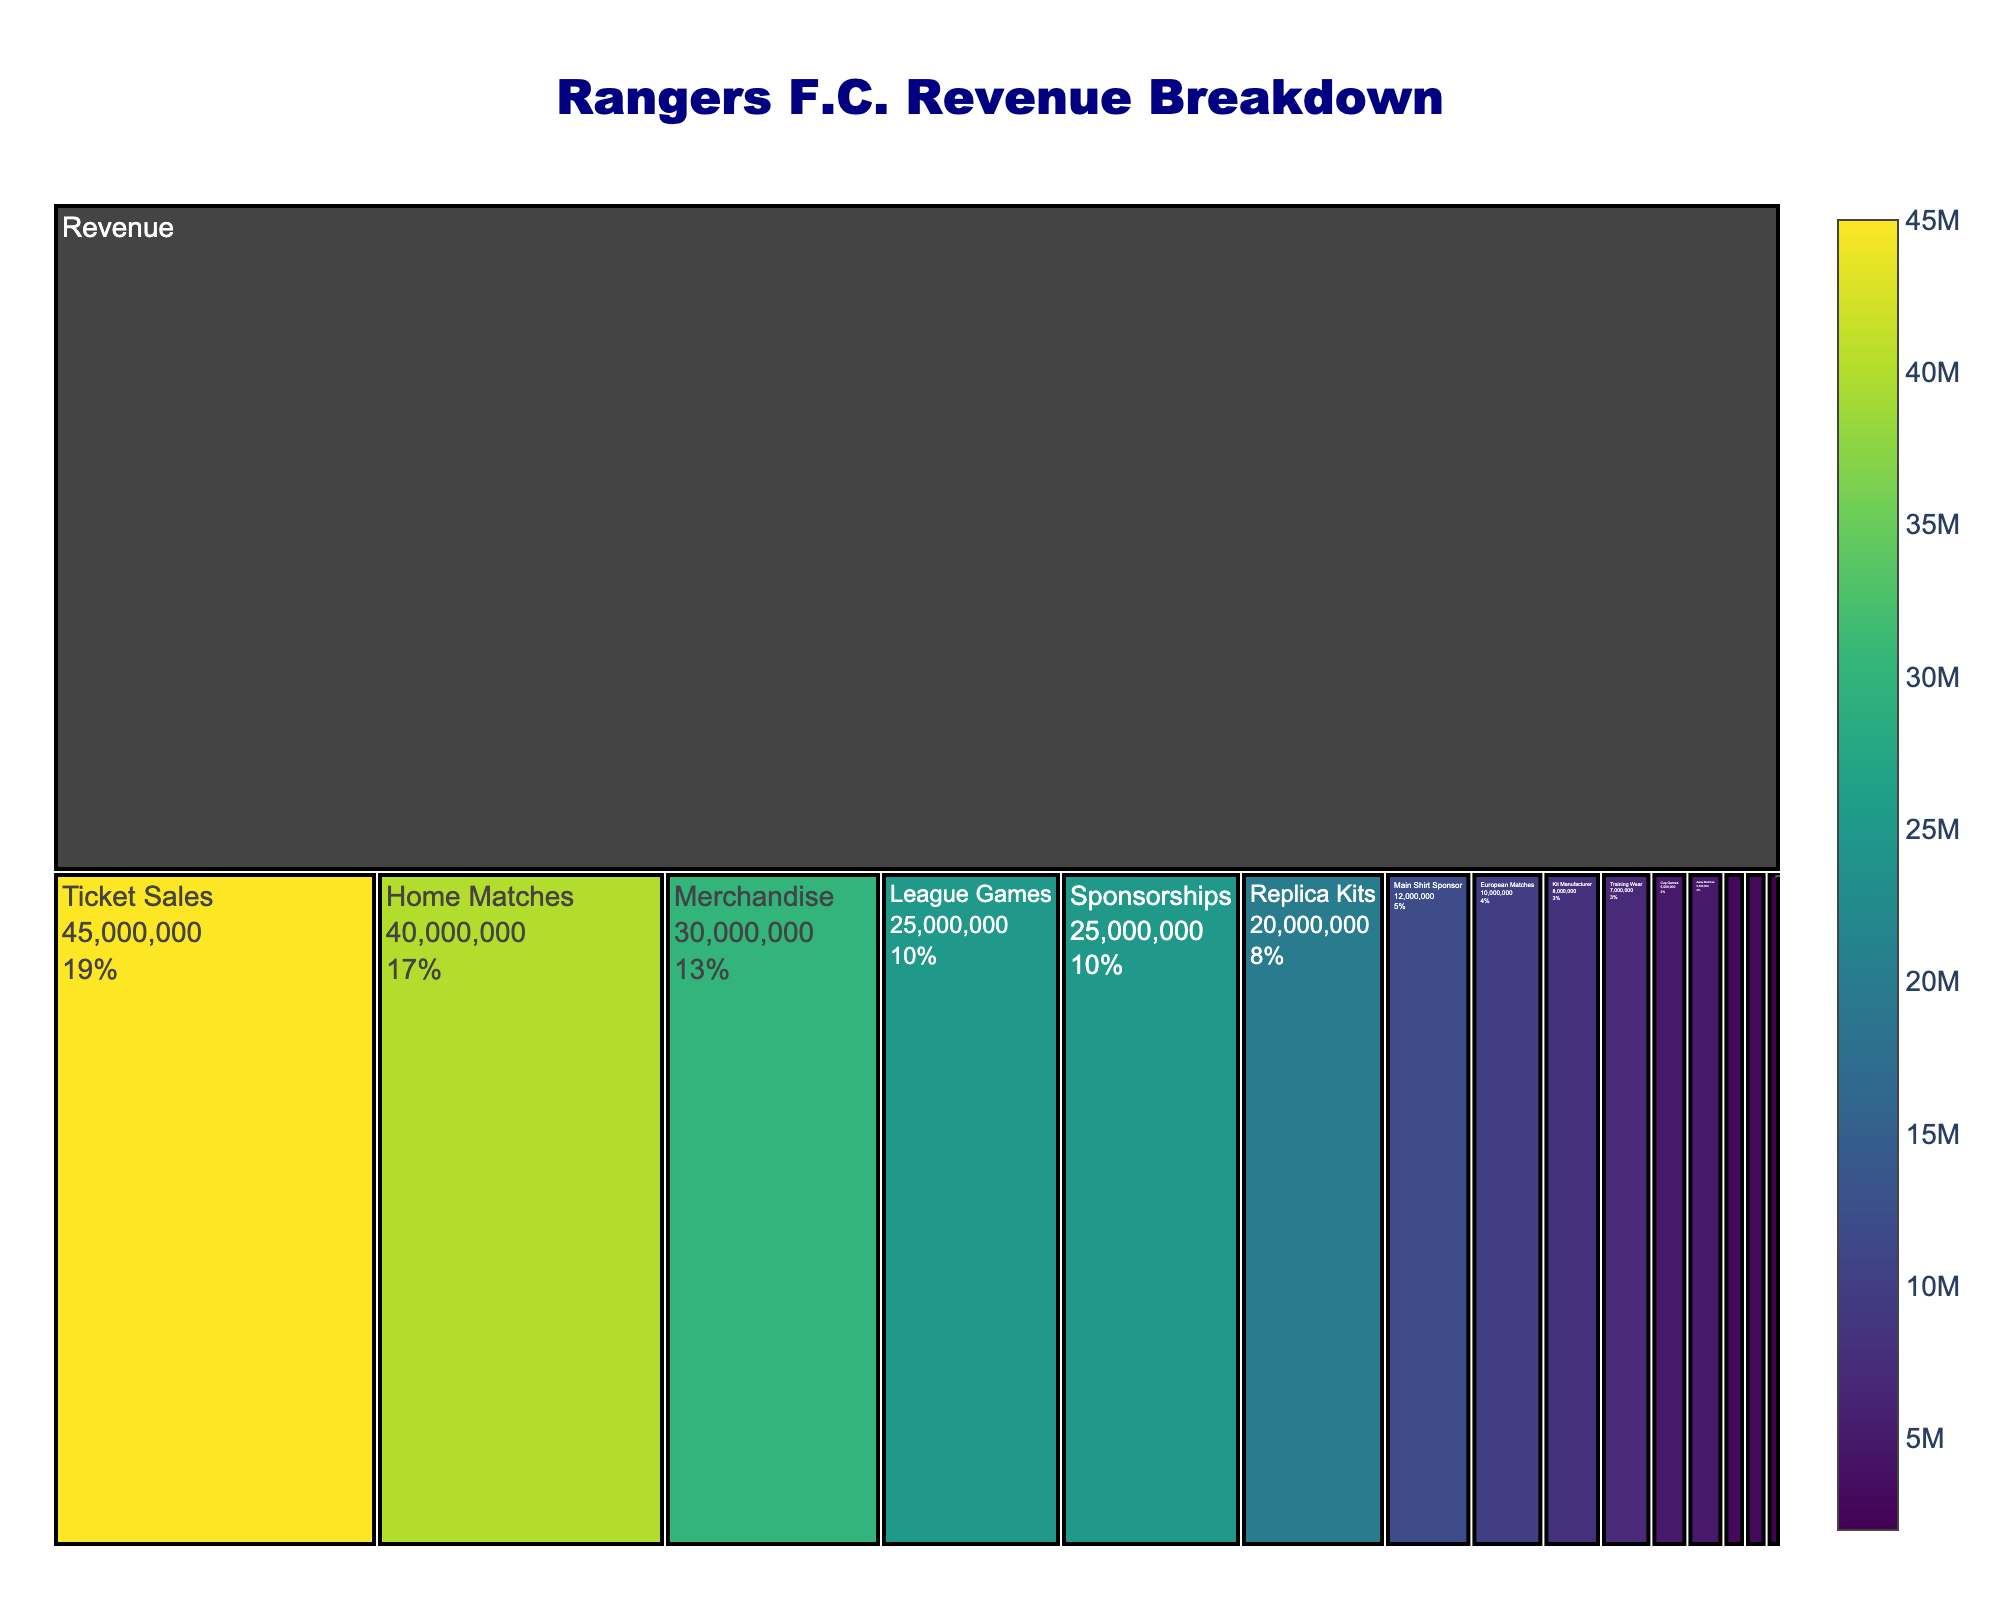What is the total revenue for Rangers F.C.? The figure's title mentions "Rangers F.C. Revenue Breakdown," and we can see that the top-level value representing all revenue streams is £100,000,000.
Answer: £100,000,000 How much revenue is generated from ticket sales? The value shown for "Ticket Sales," which is a primary source under "Revenue," is £45,000,000.
Answer: £45,000,000 What is the revenue from merchandise sales? The value for "Merchandise" under "Revenue" is shown as £30,000,000.
Answer: £30,000,000 Which revenue source contributes more, ticket sales or sponsorships? The values shown for "Ticket Sales" and "Sponsorships" are £45,000,000 and £25,000,000 respectively. Ticket sales contribute more than sponsorships.
Answer: Ticket Sales What percentage of merchandise revenue comes from replica kits? The revenue from "Replica Kits" is £20,000,000 and the total "Merchandise" revenue is £30,000,000. The percentage is calculated as (20,000,000 / 30,000,000) * 100 ≈ 66.67%.
Answer: 66.67% What is the combined revenue from home and away matches? "Home Matches" generate £40,000,000 and "Away Matches" generate £5,000,000. Combined revenue is 40,000,000 + 5,000,000 = £45,000,000.
Answer: £45,000,000 Which specific type of ticket sale generates the least revenue and how much? Under "Ticket Sales," the subcategory "Away Matches" generates the least revenue with £5,000,000.
Answer: Away Matches, £5,000,000 How much less revenue does training wear generate compared to replica kits? "Replica Kits" generate £20,000,000 and "Training Wear" generate £7,000,000. The difference is 20,000,000 - 7,000,000 = £13,000,000.
Answer: £13,000,000 What is the percentage contribution of the main shirt sponsor to the total sponsorship revenue? The "Main Shirt Sponsor" generates £12,000,000 and the total "Sponsorships" revenue is £25,000,000. The percentage is (12,000,000 / 25,000,000) * 100 = 48%.
Answer: 48% How much revenue do European matches generate compared to league games? From "Home Matches," "European Matches" generate £10,000,000 and "League Games" generate £25,000,000. European matches generate less revenue by 25,000,000 - 10,000,000 = £15,000,000.
Answer: £15,000,000 less 